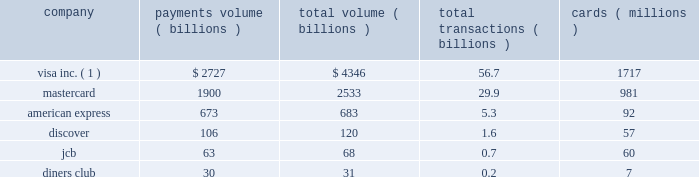Competition we compete in the global payment marketplace against all forms of payment , including paper- based forms ( principally cash and checks ) , card-based payments ( including credit , charge , debit , atm , prepaid , private-label and other types of general-purpose and limited-use cards ) and other electronic payments ( including wire transfers , electronic benefits transfers , automatic clearing house , or ach , payments and electronic data interchange ) .
Within the general purpose payment card industry , we face substantial and intense competition worldwide in the provision of payments services to financial institution customers and their cardholder merchants .
The leading global card brands in the general purpose payment card industry are visa , mastercard , american express and diners club .
Other general-purpose card brands are more concentrated in specific geographic regions , such as jcb in japan and discover in the united states .
In certain countries , our competitors have leading positions , such as china unionpay in china , which is the sole domestic inter-bank bankcard processor and operates the sole domestic bankcard acceptance mark in china due to local regulation .
We also compete against private-label cards , which can generally be used to make purchases solely at the sponsoring retail store , gasoline retailer or other merchant .
In the debit card market segment , visa and mastercard are the primary global brands .
In addition , our interlink and visa electron brands compete with maestro , owned by mastercard , and various regional and country-specific debit network brands .
In addition to our plus brand , the primary cash access card brands are cirrus , owned by mastercard , and many of the online debit network brands referenced above .
In many countries , local debit brands are the primary brands , and our brands are used primarily to enable cross-border transactions , which typically constitute a small portion of overall transaction volume .
See item 8 2014financial statements and supplementary data for financial information about geographic areas .
Based on payments volume , total volume , number of transactions and number of cards in circulation , visa is the largest retail electronic payments network in the world .
The following chart compares our network with those of our major general-purpose payment network competitors for calendar year 2008 : company payments volume volume transactions cards ( billions ) ( billions ) ( billions ) ( millions ) visa inc. ( 1 ) .
$ 2727 $ 4346 56.7 1717 .
( 1 ) visa inc .
Figures as reported on form 8-k filed with the sec on april 29 , 2009 .
Source : the nilson report , issue 924 ( april 2009 ) and issue 925 ( may 2009 ) .
Note : visa inc .
Figures exclude visa europe .
Figures for competitors include their respective european operations .
Visa figures include visa , visa electron , and interlink brands .
The visa card figure includes plus-only cards ( with no visa logo ) in all regions except the united states , but plus cash volume is not included .
Domestic china figures including commercial funds transfers are excluded .
Mastercard includes pin-based debit card figures on mastercard cards , but not maestro or cirrus figures .
American express includes business from third-party issuers .
Jcb figures are for april 2007 through march 2008 , but cards are as of september 2008 .
Transaction figures are estimates .
Figures include business from third-party issuers. .
What is the average payment volume per transaction of visa inc? 
Computations: (2727 / 56.7)
Answer: 48.09524. 